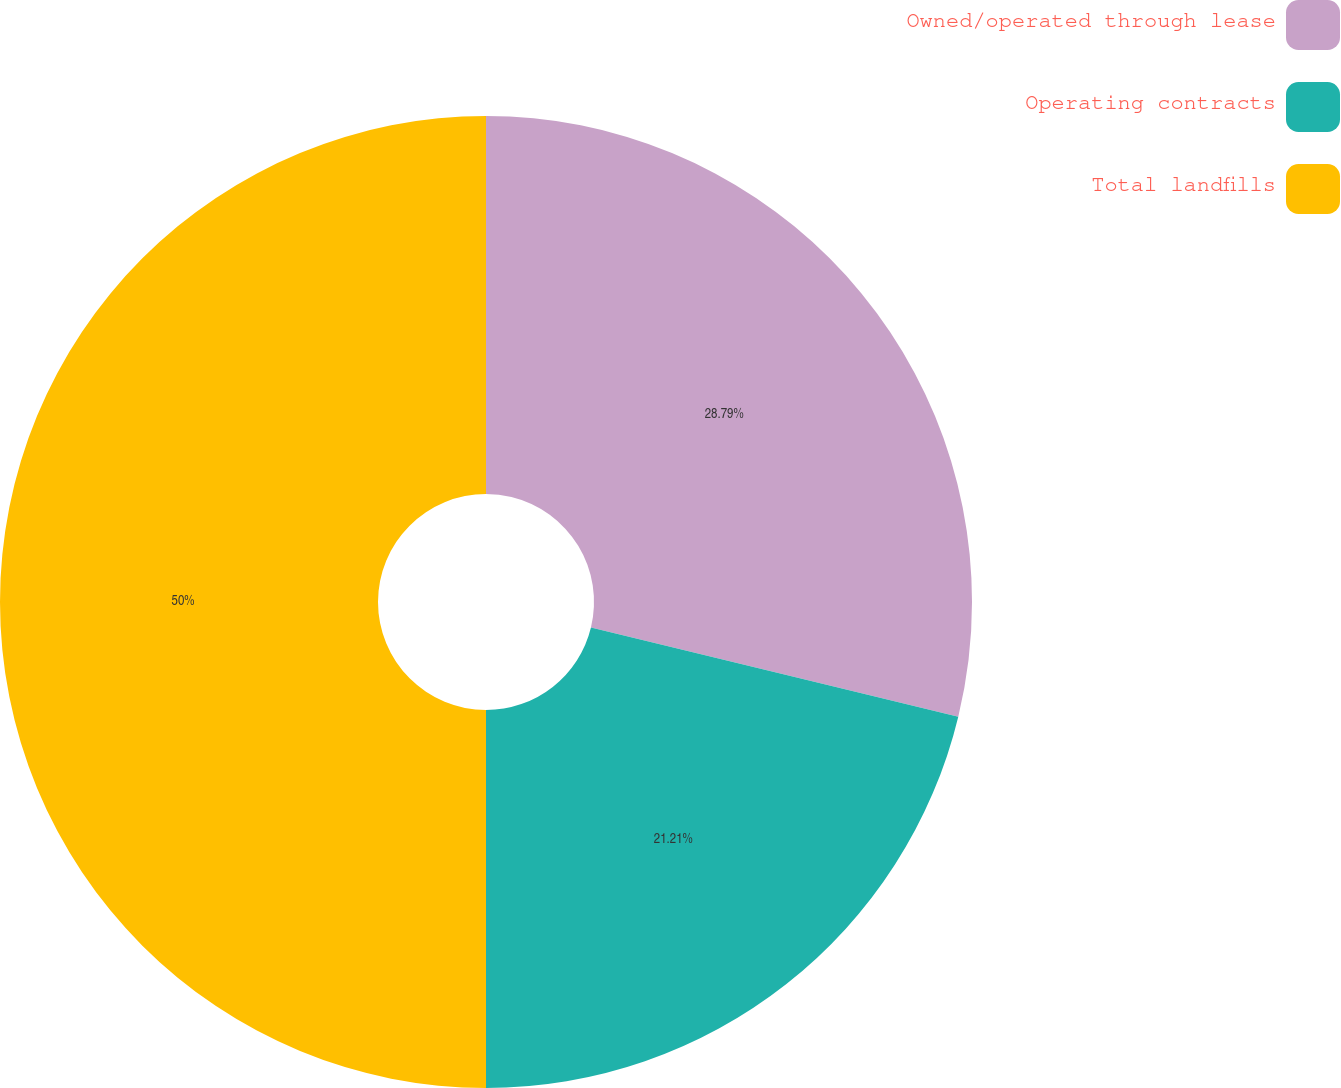Convert chart to OTSL. <chart><loc_0><loc_0><loc_500><loc_500><pie_chart><fcel>Owned/operated through lease<fcel>Operating contracts<fcel>Total landfills<nl><fcel>28.79%<fcel>21.21%<fcel>50.0%<nl></chart> 